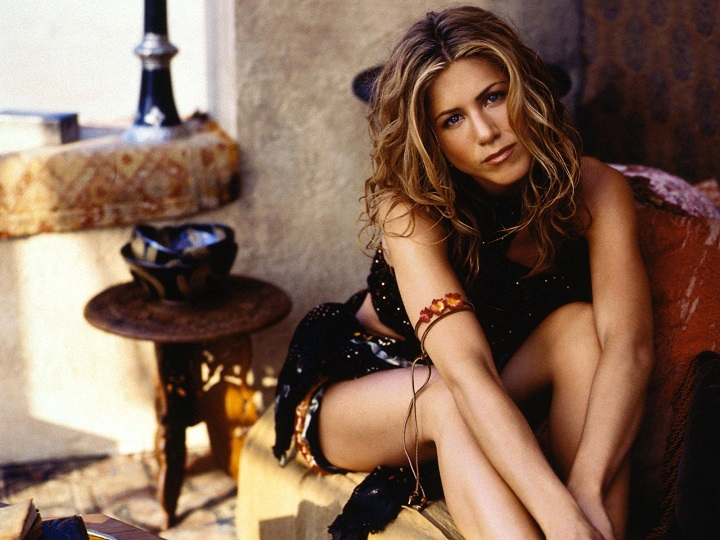How does the lighting in the photograph affect the mood? The warm, soft lighting in the photograph creates a cozy and inviting atmosphere. It enhances the rustic charm of the furniture and casts gentle shadows that give the scene a relaxed, tranquil feel. The light seems to emulate the late afternoon sun, which is typical of leisurely days in Mediterranean settings, adding to the overall sense of calm and comfort. 